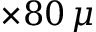Convert formula to latex. <formula><loc_0><loc_0><loc_500><loc_500>\times 8 0 \, \mu</formula> 